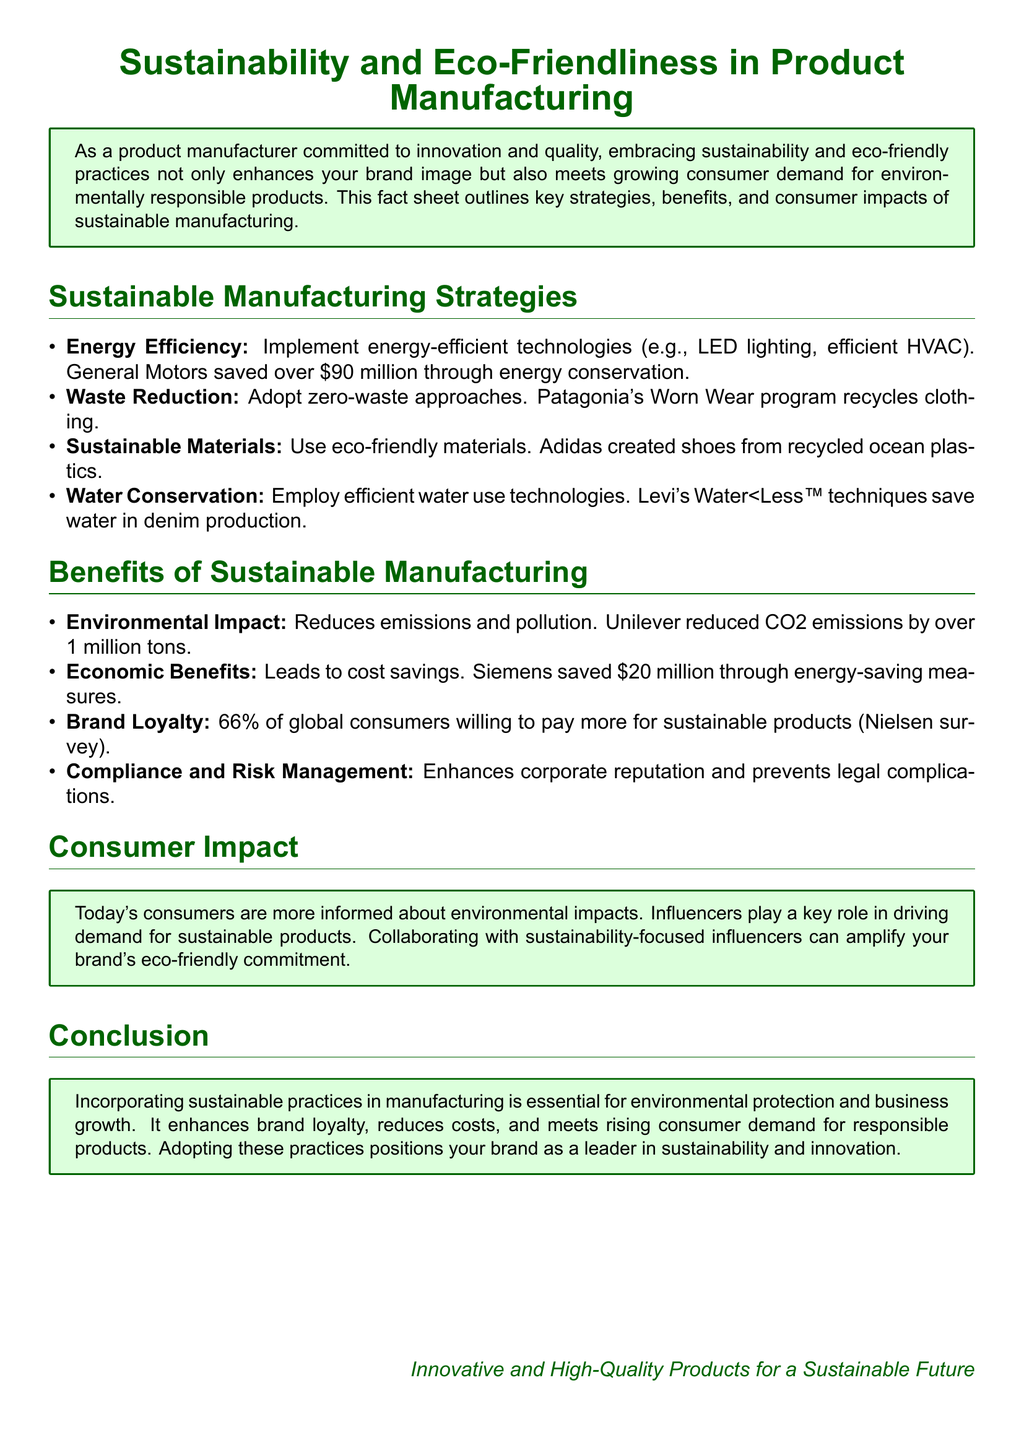What is one example of a sustainable material used in manufacturing? Adidas created shoes from recycled ocean plastics.
Answer: recycled ocean plastics How much did General Motors save through energy conservation? General Motors saved over $90 million through energy conservation.
Answer: $90 million What percentage of global consumers are willing to pay more for sustainable products? 66% of global consumers willing to pay more for sustainable products (Nielsen survey).
Answer: 66% What program does Patagonia use to recycle clothing? Patagonia's Worn Wear program recycles clothing.
Answer: Worn Wear program What is the main role of influencers in promoting sustainable products? Influencers play a key role in driving demand for sustainable products.
Answer: driving demand How much did Unilever reduce CO2 emissions by? Unilever reduced CO2 emissions by over 1 million tons.
Answer: 1 million tons 